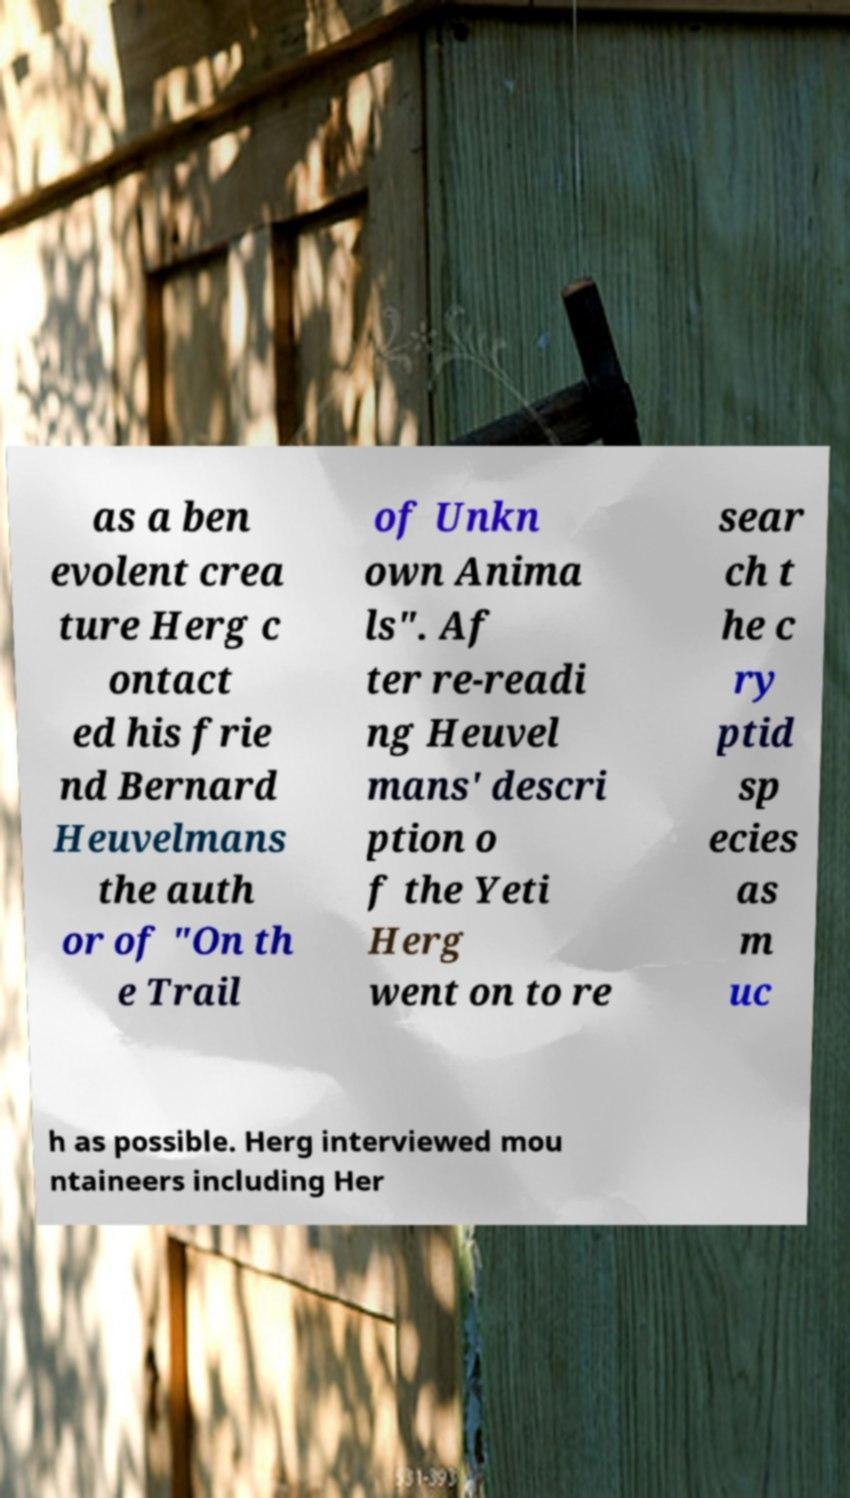I need the written content from this picture converted into text. Can you do that? as a ben evolent crea ture Herg c ontact ed his frie nd Bernard Heuvelmans the auth or of "On th e Trail of Unkn own Anima ls". Af ter re-readi ng Heuvel mans' descri ption o f the Yeti Herg went on to re sear ch t he c ry ptid sp ecies as m uc h as possible. Herg interviewed mou ntaineers including Her 